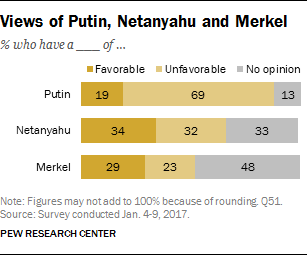Outline some significant characteristics in this image. The difference between the highest and lowest grey bar is 35. What color has the value of 13? It is gray. 